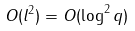Convert formula to latex. <formula><loc_0><loc_0><loc_500><loc_500>O ( l ^ { 2 } ) = O ( \log ^ { 2 } q )</formula> 